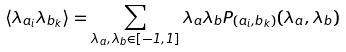Convert formula to latex. <formula><loc_0><loc_0><loc_500><loc_500>\langle \lambda _ { a _ { i } } \lambda _ { b _ { k } } \rangle = \sum _ { \lambda _ { a } , \lambda _ { b } \in [ - 1 , 1 ] } \lambda _ { a } \lambda _ { b } P _ { ( a _ { i } , b _ { k } ) } ( \lambda _ { a } , \lambda _ { b } )</formula> 